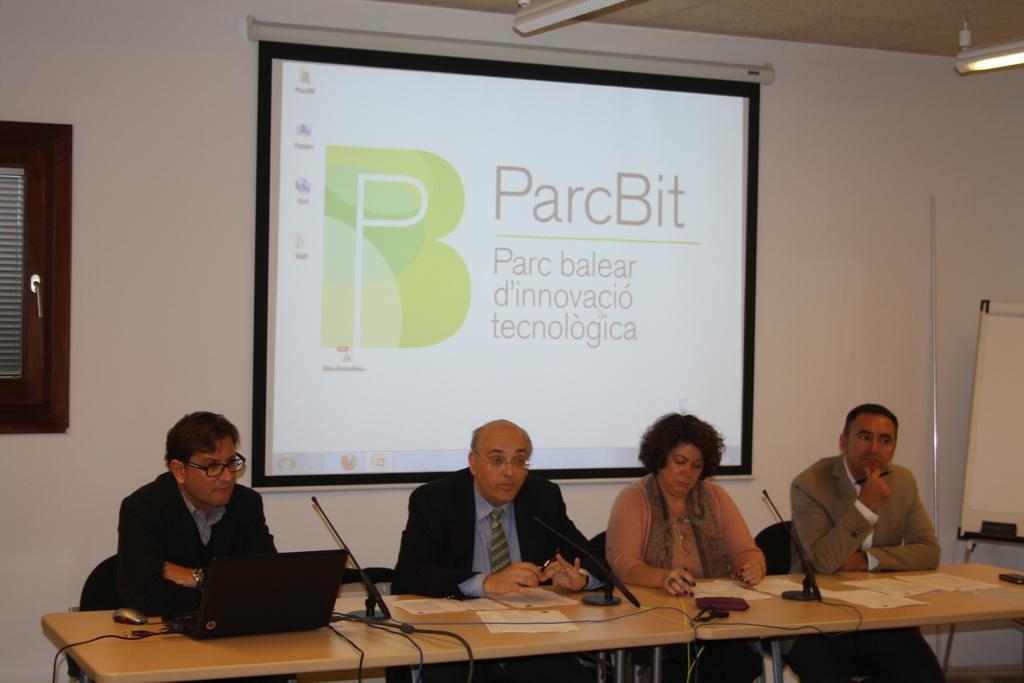Please provide a concise description of this image. This picture is taken in a room. At the bottom, there are four persons sitting beside the table. There are three men and a woman. All the three men are wearing blazers and woman is wearing a brown top and scarf. On the table, there are laptops, mike's, papers etc were placed. Behind them ,there is a projector screen. At the left, there is a window. At the top right, there is a light. 